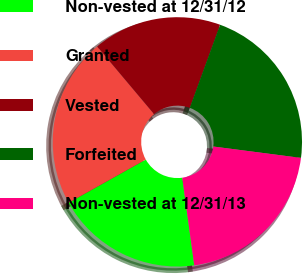<chart> <loc_0><loc_0><loc_500><loc_500><pie_chart><fcel>Non-vested at 12/31/12<fcel>Granted<fcel>Vested<fcel>Forfeited<fcel>Non-vested at 12/31/13<nl><fcel>19.04%<fcel>22.0%<fcel>16.7%<fcel>21.49%<fcel>20.78%<nl></chart> 